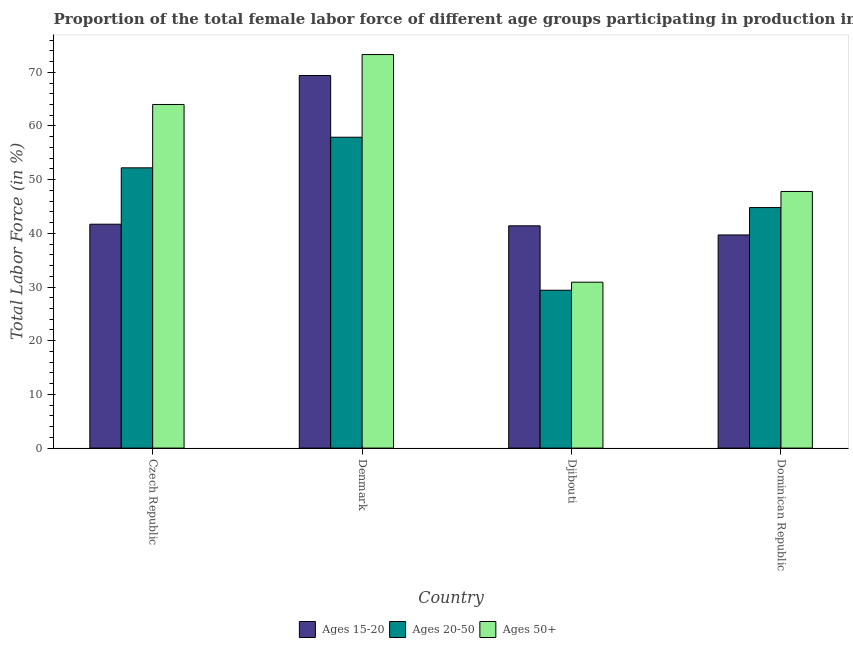How many different coloured bars are there?
Ensure brevity in your answer.  3. How many groups of bars are there?
Ensure brevity in your answer.  4. Are the number of bars per tick equal to the number of legend labels?
Your answer should be compact. Yes. Are the number of bars on each tick of the X-axis equal?
Ensure brevity in your answer.  Yes. What is the label of the 3rd group of bars from the left?
Your response must be concise. Djibouti. What is the percentage of female labor force within the age group 20-50 in Denmark?
Offer a terse response. 57.9. Across all countries, what is the maximum percentage of female labor force within the age group 15-20?
Keep it short and to the point. 69.4. Across all countries, what is the minimum percentage of female labor force above age 50?
Make the answer very short. 30.9. In which country was the percentage of female labor force within the age group 20-50 maximum?
Offer a terse response. Denmark. In which country was the percentage of female labor force above age 50 minimum?
Ensure brevity in your answer.  Djibouti. What is the total percentage of female labor force above age 50 in the graph?
Keep it short and to the point. 216. What is the difference between the percentage of female labor force within the age group 20-50 in Denmark and that in Djibouti?
Make the answer very short. 28.5. What is the difference between the percentage of female labor force within the age group 20-50 in Denmark and the percentage of female labor force above age 50 in Czech Republic?
Give a very brief answer. -6.1. What is the average percentage of female labor force within the age group 20-50 per country?
Provide a succinct answer. 46.08. What is the difference between the percentage of female labor force within the age group 20-50 and percentage of female labor force above age 50 in Denmark?
Make the answer very short. -15.4. In how many countries, is the percentage of female labor force above age 50 greater than 50 %?
Provide a short and direct response. 2. What is the ratio of the percentage of female labor force above age 50 in Czech Republic to that in Denmark?
Provide a short and direct response. 0.87. Is the percentage of female labor force above age 50 in Denmark less than that in Dominican Republic?
Offer a very short reply. No. What is the difference between the highest and the second highest percentage of female labor force within the age group 15-20?
Your response must be concise. 27.7. What is the difference between the highest and the lowest percentage of female labor force within the age group 15-20?
Your answer should be compact. 29.7. In how many countries, is the percentage of female labor force above age 50 greater than the average percentage of female labor force above age 50 taken over all countries?
Offer a very short reply. 2. What does the 1st bar from the left in Dominican Republic represents?
Your answer should be very brief. Ages 15-20. What does the 1st bar from the right in Dominican Republic represents?
Offer a terse response. Ages 50+. Are all the bars in the graph horizontal?
Provide a succinct answer. No. How many countries are there in the graph?
Provide a short and direct response. 4. What is the difference between two consecutive major ticks on the Y-axis?
Provide a succinct answer. 10. Are the values on the major ticks of Y-axis written in scientific E-notation?
Offer a very short reply. No. Does the graph contain any zero values?
Offer a very short reply. No. Where does the legend appear in the graph?
Offer a very short reply. Bottom center. What is the title of the graph?
Make the answer very short. Proportion of the total female labor force of different age groups participating in production in 1995. What is the Total Labor Force (in %) in Ages 15-20 in Czech Republic?
Ensure brevity in your answer.  41.7. What is the Total Labor Force (in %) in Ages 20-50 in Czech Republic?
Ensure brevity in your answer.  52.2. What is the Total Labor Force (in %) of Ages 15-20 in Denmark?
Offer a very short reply. 69.4. What is the Total Labor Force (in %) in Ages 20-50 in Denmark?
Your answer should be very brief. 57.9. What is the Total Labor Force (in %) in Ages 50+ in Denmark?
Your answer should be very brief. 73.3. What is the Total Labor Force (in %) in Ages 15-20 in Djibouti?
Offer a terse response. 41.4. What is the Total Labor Force (in %) of Ages 20-50 in Djibouti?
Offer a very short reply. 29.4. What is the Total Labor Force (in %) in Ages 50+ in Djibouti?
Provide a succinct answer. 30.9. What is the Total Labor Force (in %) of Ages 15-20 in Dominican Republic?
Provide a short and direct response. 39.7. What is the Total Labor Force (in %) of Ages 20-50 in Dominican Republic?
Your response must be concise. 44.8. What is the Total Labor Force (in %) of Ages 50+ in Dominican Republic?
Offer a very short reply. 47.8. Across all countries, what is the maximum Total Labor Force (in %) in Ages 15-20?
Give a very brief answer. 69.4. Across all countries, what is the maximum Total Labor Force (in %) of Ages 20-50?
Keep it short and to the point. 57.9. Across all countries, what is the maximum Total Labor Force (in %) in Ages 50+?
Your answer should be compact. 73.3. Across all countries, what is the minimum Total Labor Force (in %) in Ages 15-20?
Give a very brief answer. 39.7. Across all countries, what is the minimum Total Labor Force (in %) of Ages 20-50?
Your answer should be compact. 29.4. Across all countries, what is the minimum Total Labor Force (in %) of Ages 50+?
Make the answer very short. 30.9. What is the total Total Labor Force (in %) of Ages 15-20 in the graph?
Keep it short and to the point. 192.2. What is the total Total Labor Force (in %) in Ages 20-50 in the graph?
Keep it short and to the point. 184.3. What is the total Total Labor Force (in %) in Ages 50+ in the graph?
Offer a very short reply. 216. What is the difference between the Total Labor Force (in %) in Ages 15-20 in Czech Republic and that in Denmark?
Your answer should be very brief. -27.7. What is the difference between the Total Labor Force (in %) in Ages 20-50 in Czech Republic and that in Denmark?
Your answer should be very brief. -5.7. What is the difference between the Total Labor Force (in %) in Ages 50+ in Czech Republic and that in Denmark?
Your answer should be compact. -9.3. What is the difference between the Total Labor Force (in %) of Ages 20-50 in Czech Republic and that in Djibouti?
Your answer should be very brief. 22.8. What is the difference between the Total Labor Force (in %) of Ages 50+ in Czech Republic and that in Djibouti?
Your response must be concise. 33.1. What is the difference between the Total Labor Force (in %) in Ages 15-20 in Czech Republic and that in Dominican Republic?
Your answer should be very brief. 2. What is the difference between the Total Labor Force (in %) of Ages 50+ in Czech Republic and that in Dominican Republic?
Your response must be concise. 16.2. What is the difference between the Total Labor Force (in %) of Ages 50+ in Denmark and that in Djibouti?
Ensure brevity in your answer.  42.4. What is the difference between the Total Labor Force (in %) in Ages 15-20 in Denmark and that in Dominican Republic?
Your answer should be compact. 29.7. What is the difference between the Total Labor Force (in %) of Ages 20-50 in Denmark and that in Dominican Republic?
Offer a terse response. 13.1. What is the difference between the Total Labor Force (in %) in Ages 50+ in Denmark and that in Dominican Republic?
Offer a very short reply. 25.5. What is the difference between the Total Labor Force (in %) in Ages 20-50 in Djibouti and that in Dominican Republic?
Make the answer very short. -15.4. What is the difference between the Total Labor Force (in %) of Ages 50+ in Djibouti and that in Dominican Republic?
Provide a succinct answer. -16.9. What is the difference between the Total Labor Force (in %) in Ages 15-20 in Czech Republic and the Total Labor Force (in %) in Ages 20-50 in Denmark?
Your answer should be compact. -16.2. What is the difference between the Total Labor Force (in %) in Ages 15-20 in Czech Republic and the Total Labor Force (in %) in Ages 50+ in Denmark?
Give a very brief answer. -31.6. What is the difference between the Total Labor Force (in %) of Ages 20-50 in Czech Republic and the Total Labor Force (in %) of Ages 50+ in Denmark?
Offer a terse response. -21.1. What is the difference between the Total Labor Force (in %) in Ages 15-20 in Czech Republic and the Total Labor Force (in %) in Ages 20-50 in Djibouti?
Offer a terse response. 12.3. What is the difference between the Total Labor Force (in %) in Ages 20-50 in Czech Republic and the Total Labor Force (in %) in Ages 50+ in Djibouti?
Your response must be concise. 21.3. What is the difference between the Total Labor Force (in %) of Ages 15-20 in Denmark and the Total Labor Force (in %) of Ages 20-50 in Djibouti?
Your answer should be very brief. 40. What is the difference between the Total Labor Force (in %) in Ages 15-20 in Denmark and the Total Labor Force (in %) in Ages 50+ in Djibouti?
Provide a succinct answer. 38.5. What is the difference between the Total Labor Force (in %) of Ages 20-50 in Denmark and the Total Labor Force (in %) of Ages 50+ in Djibouti?
Offer a terse response. 27. What is the difference between the Total Labor Force (in %) in Ages 15-20 in Denmark and the Total Labor Force (in %) in Ages 20-50 in Dominican Republic?
Provide a succinct answer. 24.6. What is the difference between the Total Labor Force (in %) in Ages 15-20 in Denmark and the Total Labor Force (in %) in Ages 50+ in Dominican Republic?
Offer a very short reply. 21.6. What is the difference between the Total Labor Force (in %) in Ages 20-50 in Denmark and the Total Labor Force (in %) in Ages 50+ in Dominican Republic?
Keep it short and to the point. 10.1. What is the difference between the Total Labor Force (in %) in Ages 15-20 in Djibouti and the Total Labor Force (in %) in Ages 20-50 in Dominican Republic?
Your response must be concise. -3.4. What is the difference between the Total Labor Force (in %) in Ages 20-50 in Djibouti and the Total Labor Force (in %) in Ages 50+ in Dominican Republic?
Ensure brevity in your answer.  -18.4. What is the average Total Labor Force (in %) in Ages 15-20 per country?
Offer a very short reply. 48.05. What is the average Total Labor Force (in %) in Ages 20-50 per country?
Keep it short and to the point. 46.08. What is the difference between the Total Labor Force (in %) of Ages 15-20 and Total Labor Force (in %) of Ages 20-50 in Czech Republic?
Your response must be concise. -10.5. What is the difference between the Total Labor Force (in %) in Ages 15-20 and Total Labor Force (in %) in Ages 50+ in Czech Republic?
Offer a terse response. -22.3. What is the difference between the Total Labor Force (in %) of Ages 20-50 and Total Labor Force (in %) of Ages 50+ in Czech Republic?
Ensure brevity in your answer.  -11.8. What is the difference between the Total Labor Force (in %) of Ages 15-20 and Total Labor Force (in %) of Ages 20-50 in Denmark?
Provide a succinct answer. 11.5. What is the difference between the Total Labor Force (in %) of Ages 15-20 and Total Labor Force (in %) of Ages 50+ in Denmark?
Provide a short and direct response. -3.9. What is the difference between the Total Labor Force (in %) in Ages 20-50 and Total Labor Force (in %) in Ages 50+ in Denmark?
Your answer should be very brief. -15.4. What is the difference between the Total Labor Force (in %) in Ages 15-20 and Total Labor Force (in %) in Ages 20-50 in Djibouti?
Offer a terse response. 12. What is the difference between the Total Labor Force (in %) in Ages 20-50 and Total Labor Force (in %) in Ages 50+ in Dominican Republic?
Your answer should be very brief. -3. What is the ratio of the Total Labor Force (in %) of Ages 15-20 in Czech Republic to that in Denmark?
Your answer should be very brief. 0.6. What is the ratio of the Total Labor Force (in %) of Ages 20-50 in Czech Republic to that in Denmark?
Offer a very short reply. 0.9. What is the ratio of the Total Labor Force (in %) of Ages 50+ in Czech Republic to that in Denmark?
Keep it short and to the point. 0.87. What is the ratio of the Total Labor Force (in %) in Ages 20-50 in Czech Republic to that in Djibouti?
Your answer should be very brief. 1.78. What is the ratio of the Total Labor Force (in %) of Ages 50+ in Czech Republic to that in Djibouti?
Make the answer very short. 2.07. What is the ratio of the Total Labor Force (in %) in Ages 15-20 in Czech Republic to that in Dominican Republic?
Your response must be concise. 1.05. What is the ratio of the Total Labor Force (in %) of Ages 20-50 in Czech Republic to that in Dominican Republic?
Your answer should be compact. 1.17. What is the ratio of the Total Labor Force (in %) of Ages 50+ in Czech Republic to that in Dominican Republic?
Your answer should be compact. 1.34. What is the ratio of the Total Labor Force (in %) of Ages 15-20 in Denmark to that in Djibouti?
Keep it short and to the point. 1.68. What is the ratio of the Total Labor Force (in %) in Ages 20-50 in Denmark to that in Djibouti?
Your answer should be compact. 1.97. What is the ratio of the Total Labor Force (in %) of Ages 50+ in Denmark to that in Djibouti?
Your answer should be compact. 2.37. What is the ratio of the Total Labor Force (in %) of Ages 15-20 in Denmark to that in Dominican Republic?
Keep it short and to the point. 1.75. What is the ratio of the Total Labor Force (in %) of Ages 20-50 in Denmark to that in Dominican Republic?
Your answer should be very brief. 1.29. What is the ratio of the Total Labor Force (in %) in Ages 50+ in Denmark to that in Dominican Republic?
Keep it short and to the point. 1.53. What is the ratio of the Total Labor Force (in %) in Ages 15-20 in Djibouti to that in Dominican Republic?
Your answer should be compact. 1.04. What is the ratio of the Total Labor Force (in %) of Ages 20-50 in Djibouti to that in Dominican Republic?
Your answer should be compact. 0.66. What is the ratio of the Total Labor Force (in %) of Ages 50+ in Djibouti to that in Dominican Republic?
Offer a very short reply. 0.65. What is the difference between the highest and the second highest Total Labor Force (in %) in Ages 15-20?
Give a very brief answer. 27.7. What is the difference between the highest and the second highest Total Labor Force (in %) in Ages 50+?
Offer a terse response. 9.3. What is the difference between the highest and the lowest Total Labor Force (in %) of Ages 15-20?
Keep it short and to the point. 29.7. What is the difference between the highest and the lowest Total Labor Force (in %) in Ages 50+?
Your answer should be very brief. 42.4. 